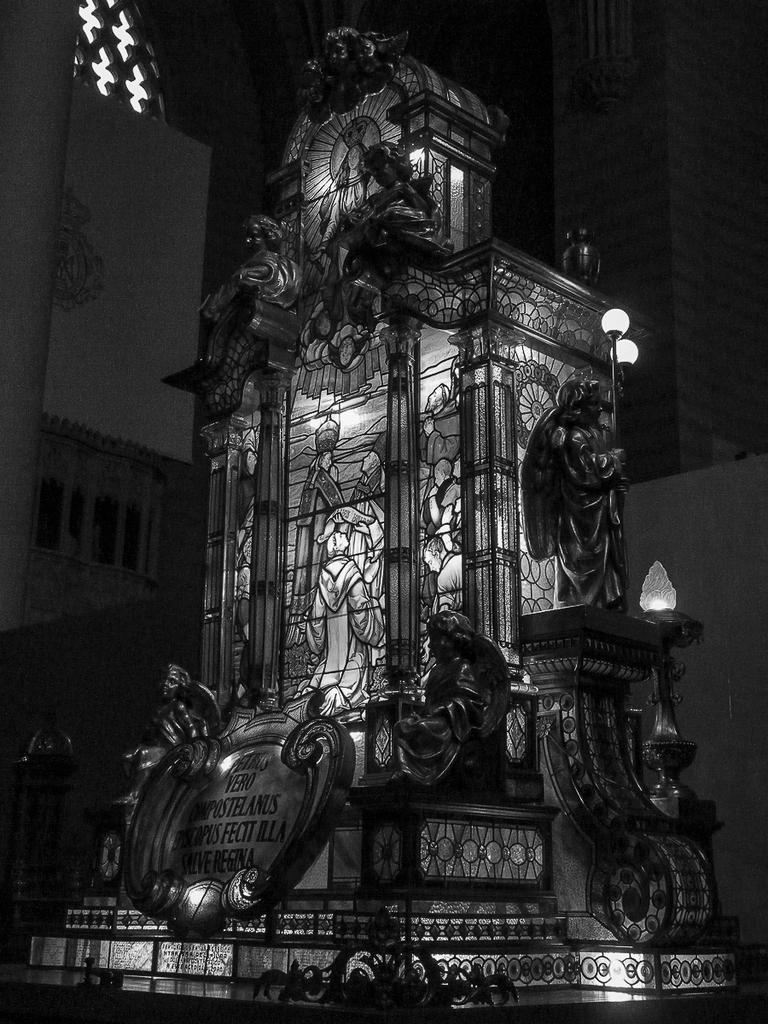Could you give a brief overview of what you see in this image? In this picture there is a monument, which is placed in the center of the image and there are lamps above it. 